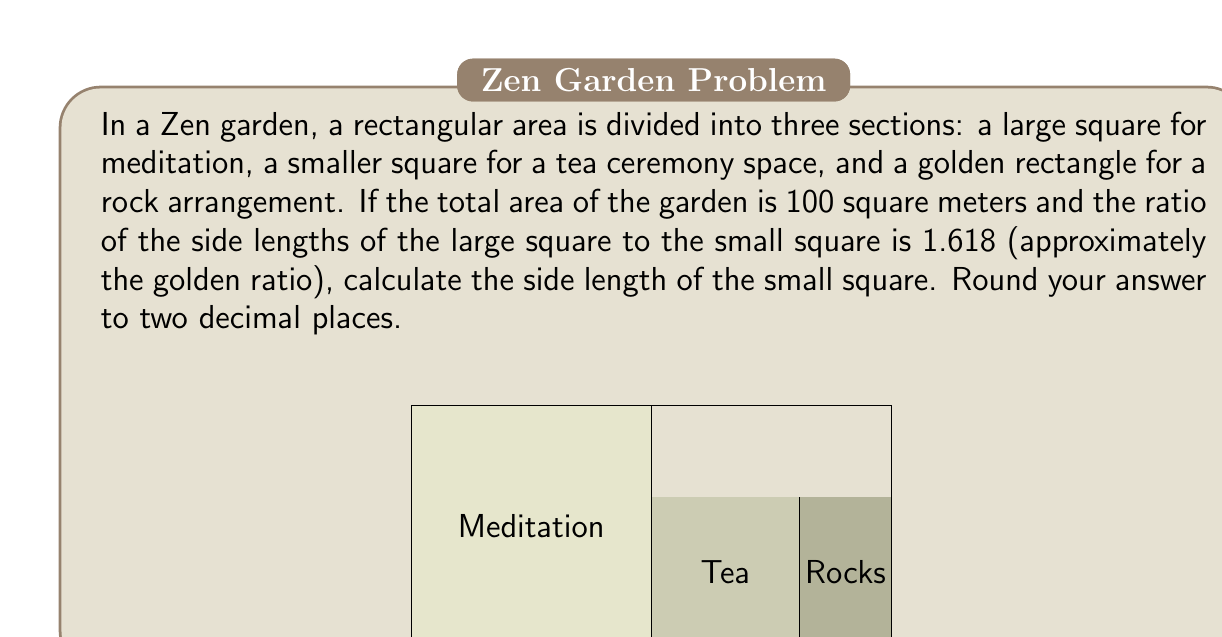Could you help me with this problem? Let's approach this step-by-step, embracing the Zen principle of mindfulness in our calculations:

1) Let the side length of the small square be $x$. Then, the side length of the large square is $1.618x$.

2) The golden rectangle's dimensions are $x$ and $1.618x$.

3) The total area of the garden is 100 sq meters. We can express this as an equation:

   $$(1.618x)^2 + x^2 + (1.618x \cdot x) = 100$$

4) Simplify the left side of the equation:

   $$2.617924x^2 + x^2 + 1.618x^2 = 100$$
   $$5.235924x^2 = 100$$

5) Solve for $x^2$:

   $$x^2 = \frac{100}{5.235924} \approx 19.099$$

6) Take the square root of both sides:

   $$x \approx \sqrt{19.099} \approx 4.37$$

7) Rounding to two decimal places:

   $$x \approx 4.37$$

Thus, the side length of the small square is approximately 4.37 meters.
Answer: $4.37$ meters 